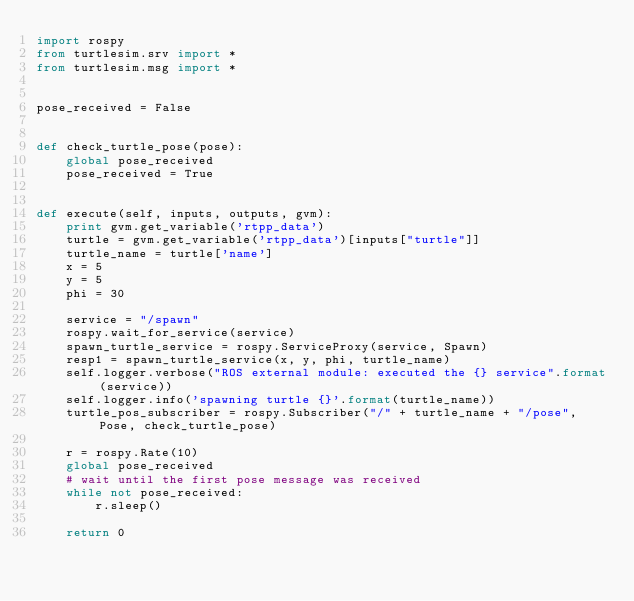Convert code to text. <code><loc_0><loc_0><loc_500><loc_500><_Python_>import rospy
from turtlesim.srv import *
from turtlesim.msg import *


pose_received = False


def check_turtle_pose(pose):
    global pose_received
    pose_received = True


def execute(self, inputs, outputs, gvm):
    print gvm.get_variable('rtpp_data')
    turtle = gvm.get_variable('rtpp_data')[inputs["turtle"]]
    turtle_name = turtle['name']
    x = 5
    y = 5
    phi = 30

    service = "/spawn"
    rospy.wait_for_service(service)
    spawn_turtle_service = rospy.ServiceProxy(service, Spawn)
    resp1 = spawn_turtle_service(x, y, phi, turtle_name)
    self.logger.verbose("ROS external module: executed the {} service".format(service))
    self.logger.info('spawning turtle {}'.format(turtle_name))
    turtle_pos_subscriber = rospy.Subscriber("/" + turtle_name + "/pose", Pose, check_turtle_pose)

    r = rospy.Rate(10)
    global pose_received
    # wait until the first pose message was received
    while not pose_received:
        r.sleep()

    return 0
</code> 